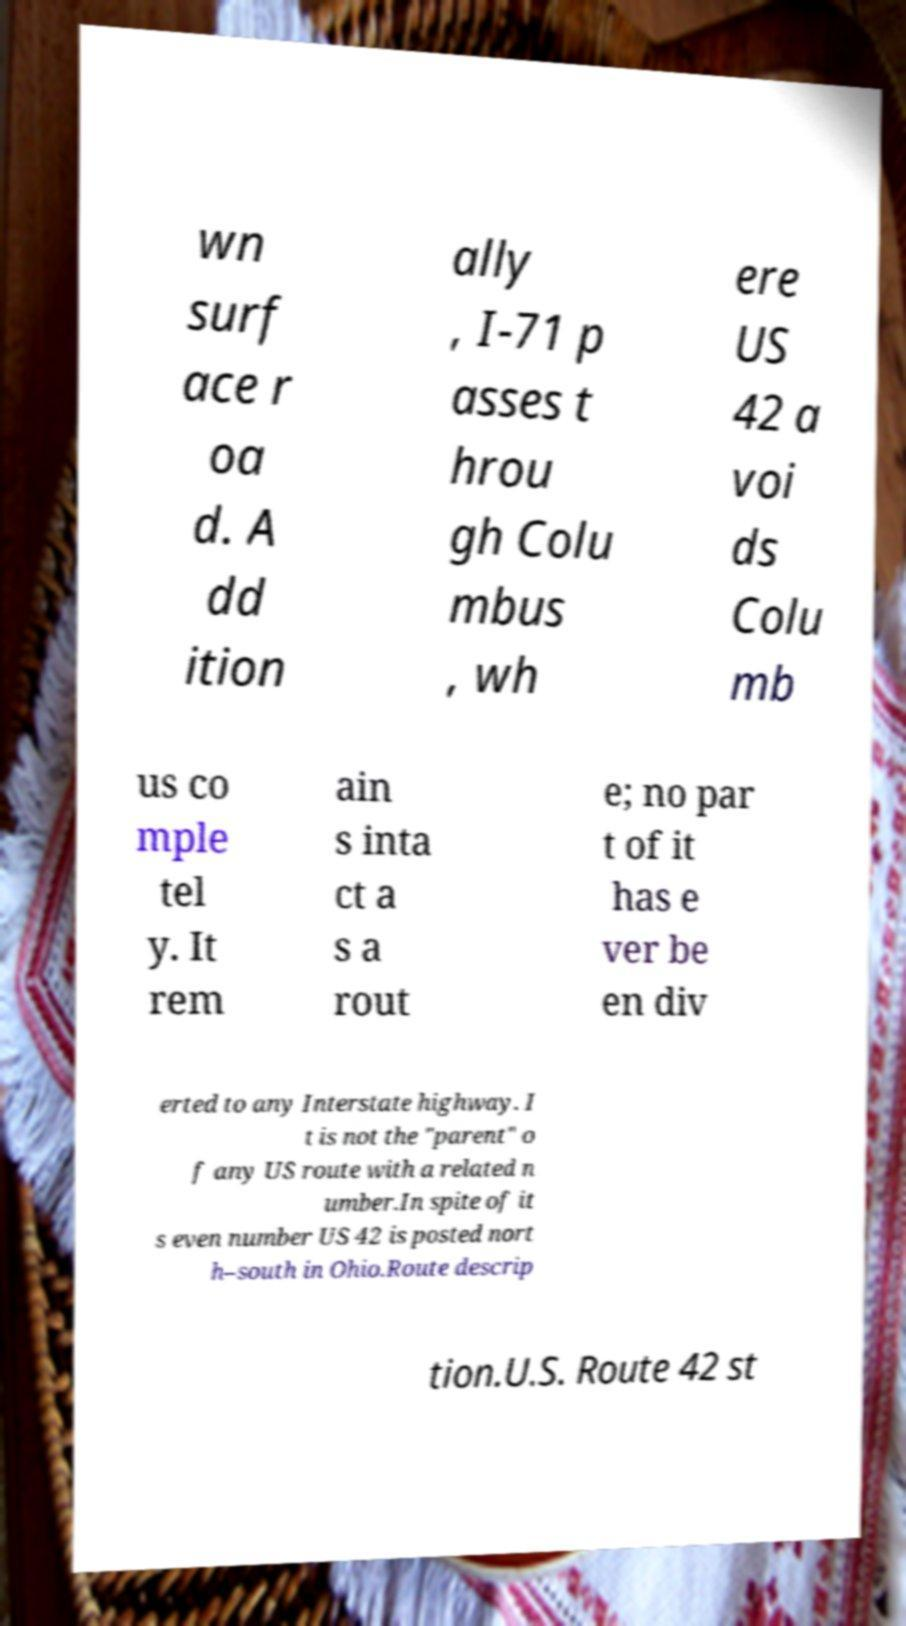Can you read and provide the text displayed in the image?This photo seems to have some interesting text. Can you extract and type it out for me? wn surf ace r oa d. A dd ition ally , I-71 p asses t hrou gh Colu mbus , wh ere US 42 a voi ds Colu mb us co mple tel y. It rem ain s inta ct a s a rout e; no par t of it has e ver be en div erted to any Interstate highway. I t is not the "parent" o f any US route with a related n umber.In spite of it s even number US 42 is posted nort h–south in Ohio.Route descrip tion.U.S. Route 42 st 